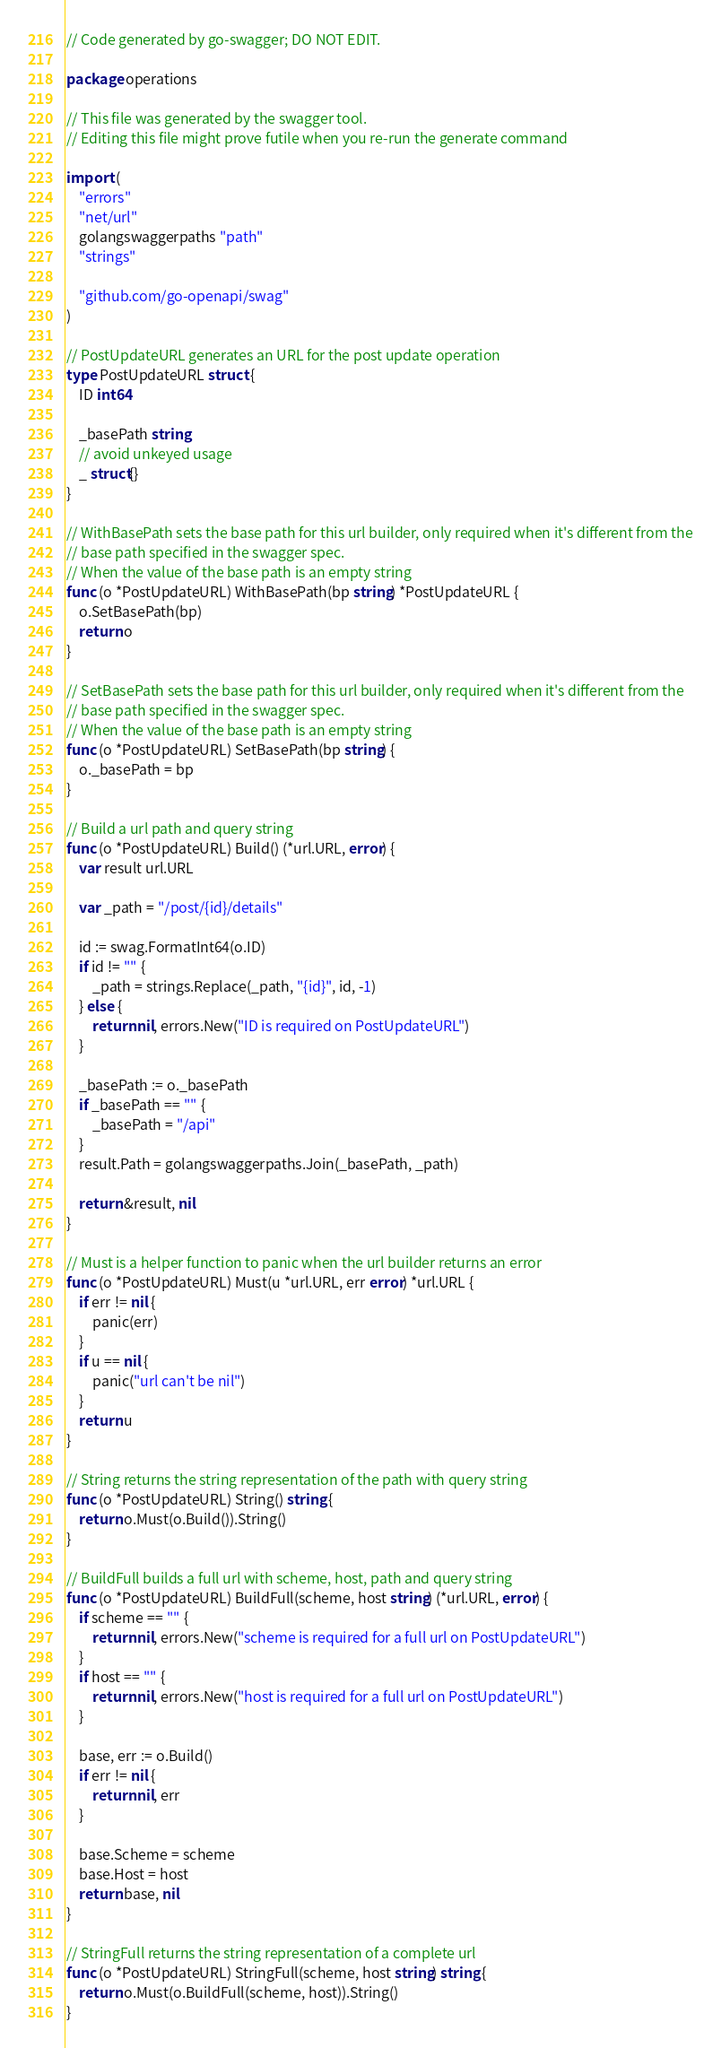<code> <loc_0><loc_0><loc_500><loc_500><_Go_>// Code generated by go-swagger; DO NOT EDIT.

package operations

// This file was generated by the swagger tool.
// Editing this file might prove futile when you re-run the generate command

import (
	"errors"
	"net/url"
	golangswaggerpaths "path"
	"strings"

	"github.com/go-openapi/swag"
)

// PostUpdateURL generates an URL for the post update operation
type PostUpdateURL struct {
	ID int64

	_basePath string
	// avoid unkeyed usage
	_ struct{}
}

// WithBasePath sets the base path for this url builder, only required when it's different from the
// base path specified in the swagger spec.
// When the value of the base path is an empty string
func (o *PostUpdateURL) WithBasePath(bp string) *PostUpdateURL {
	o.SetBasePath(bp)
	return o
}

// SetBasePath sets the base path for this url builder, only required when it's different from the
// base path specified in the swagger spec.
// When the value of the base path is an empty string
func (o *PostUpdateURL) SetBasePath(bp string) {
	o._basePath = bp
}

// Build a url path and query string
func (o *PostUpdateURL) Build() (*url.URL, error) {
	var result url.URL

	var _path = "/post/{id}/details"

	id := swag.FormatInt64(o.ID)
	if id != "" {
		_path = strings.Replace(_path, "{id}", id, -1)
	} else {
		return nil, errors.New("ID is required on PostUpdateURL")
	}

	_basePath := o._basePath
	if _basePath == "" {
		_basePath = "/api"
	}
	result.Path = golangswaggerpaths.Join(_basePath, _path)

	return &result, nil
}

// Must is a helper function to panic when the url builder returns an error
func (o *PostUpdateURL) Must(u *url.URL, err error) *url.URL {
	if err != nil {
		panic(err)
	}
	if u == nil {
		panic("url can't be nil")
	}
	return u
}

// String returns the string representation of the path with query string
func (o *PostUpdateURL) String() string {
	return o.Must(o.Build()).String()
}

// BuildFull builds a full url with scheme, host, path and query string
func (o *PostUpdateURL) BuildFull(scheme, host string) (*url.URL, error) {
	if scheme == "" {
		return nil, errors.New("scheme is required for a full url on PostUpdateURL")
	}
	if host == "" {
		return nil, errors.New("host is required for a full url on PostUpdateURL")
	}

	base, err := o.Build()
	if err != nil {
		return nil, err
	}

	base.Scheme = scheme
	base.Host = host
	return base, nil
}

// StringFull returns the string representation of a complete url
func (o *PostUpdateURL) StringFull(scheme, host string) string {
	return o.Must(o.BuildFull(scheme, host)).String()
}
</code> 